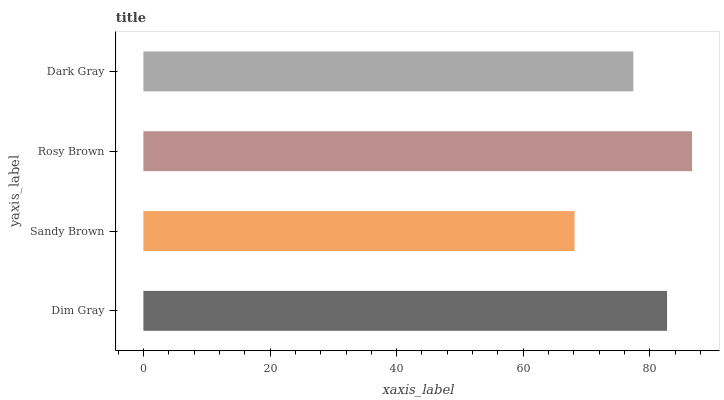Is Sandy Brown the minimum?
Answer yes or no. Yes. Is Rosy Brown the maximum?
Answer yes or no. Yes. Is Rosy Brown the minimum?
Answer yes or no. No. Is Sandy Brown the maximum?
Answer yes or no. No. Is Rosy Brown greater than Sandy Brown?
Answer yes or no. Yes. Is Sandy Brown less than Rosy Brown?
Answer yes or no. Yes. Is Sandy Brown greater than Rosy Brown?
Answer yes or no. No. Is Rosy Brown less than Sandy Brown?
Answer yes or no. No. Is Dim Gray the high median?
Answer yes or no. Yes. Is Dark Gray the low median?
Answer yes or no. Yes. Is Rosy Brown the high median?
Answer yes or no. No. Is Sandy Brown the low median?
Answer yes or no. No. 